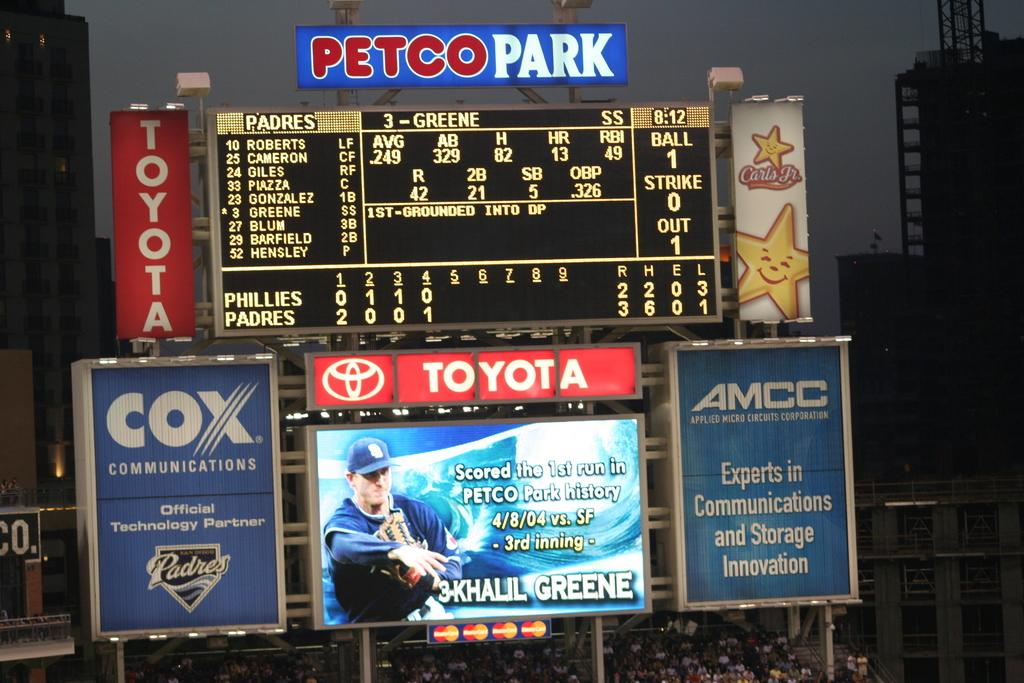<image>
Offer a succinct explanation of the picture presented. MLB scoreboard telling the amount of innings, the score and ball/strike/outs. 